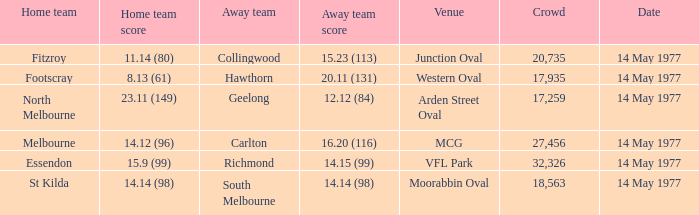I want to know the home team score of the away team of richmond that has a crowd more than 20,735 15.9 (99). 